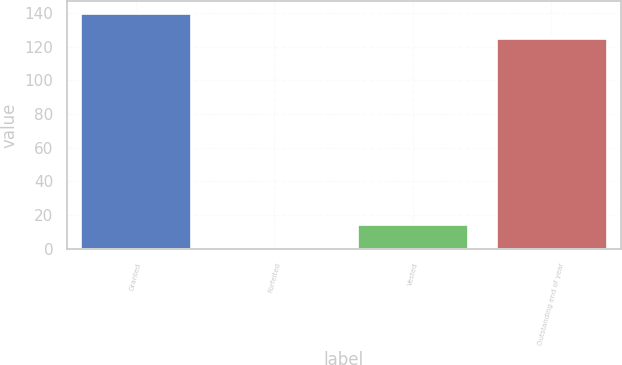<chart> <loc_0><loc_0><loc_500><loc_500><bar_chart><fcel>Granted<fcel>Forfeited<fcel>Vested<fcel>Outstanding end of year<nl><fcel>140<fcel>1<fcel>14.9<fcel>125<nl></chart> 